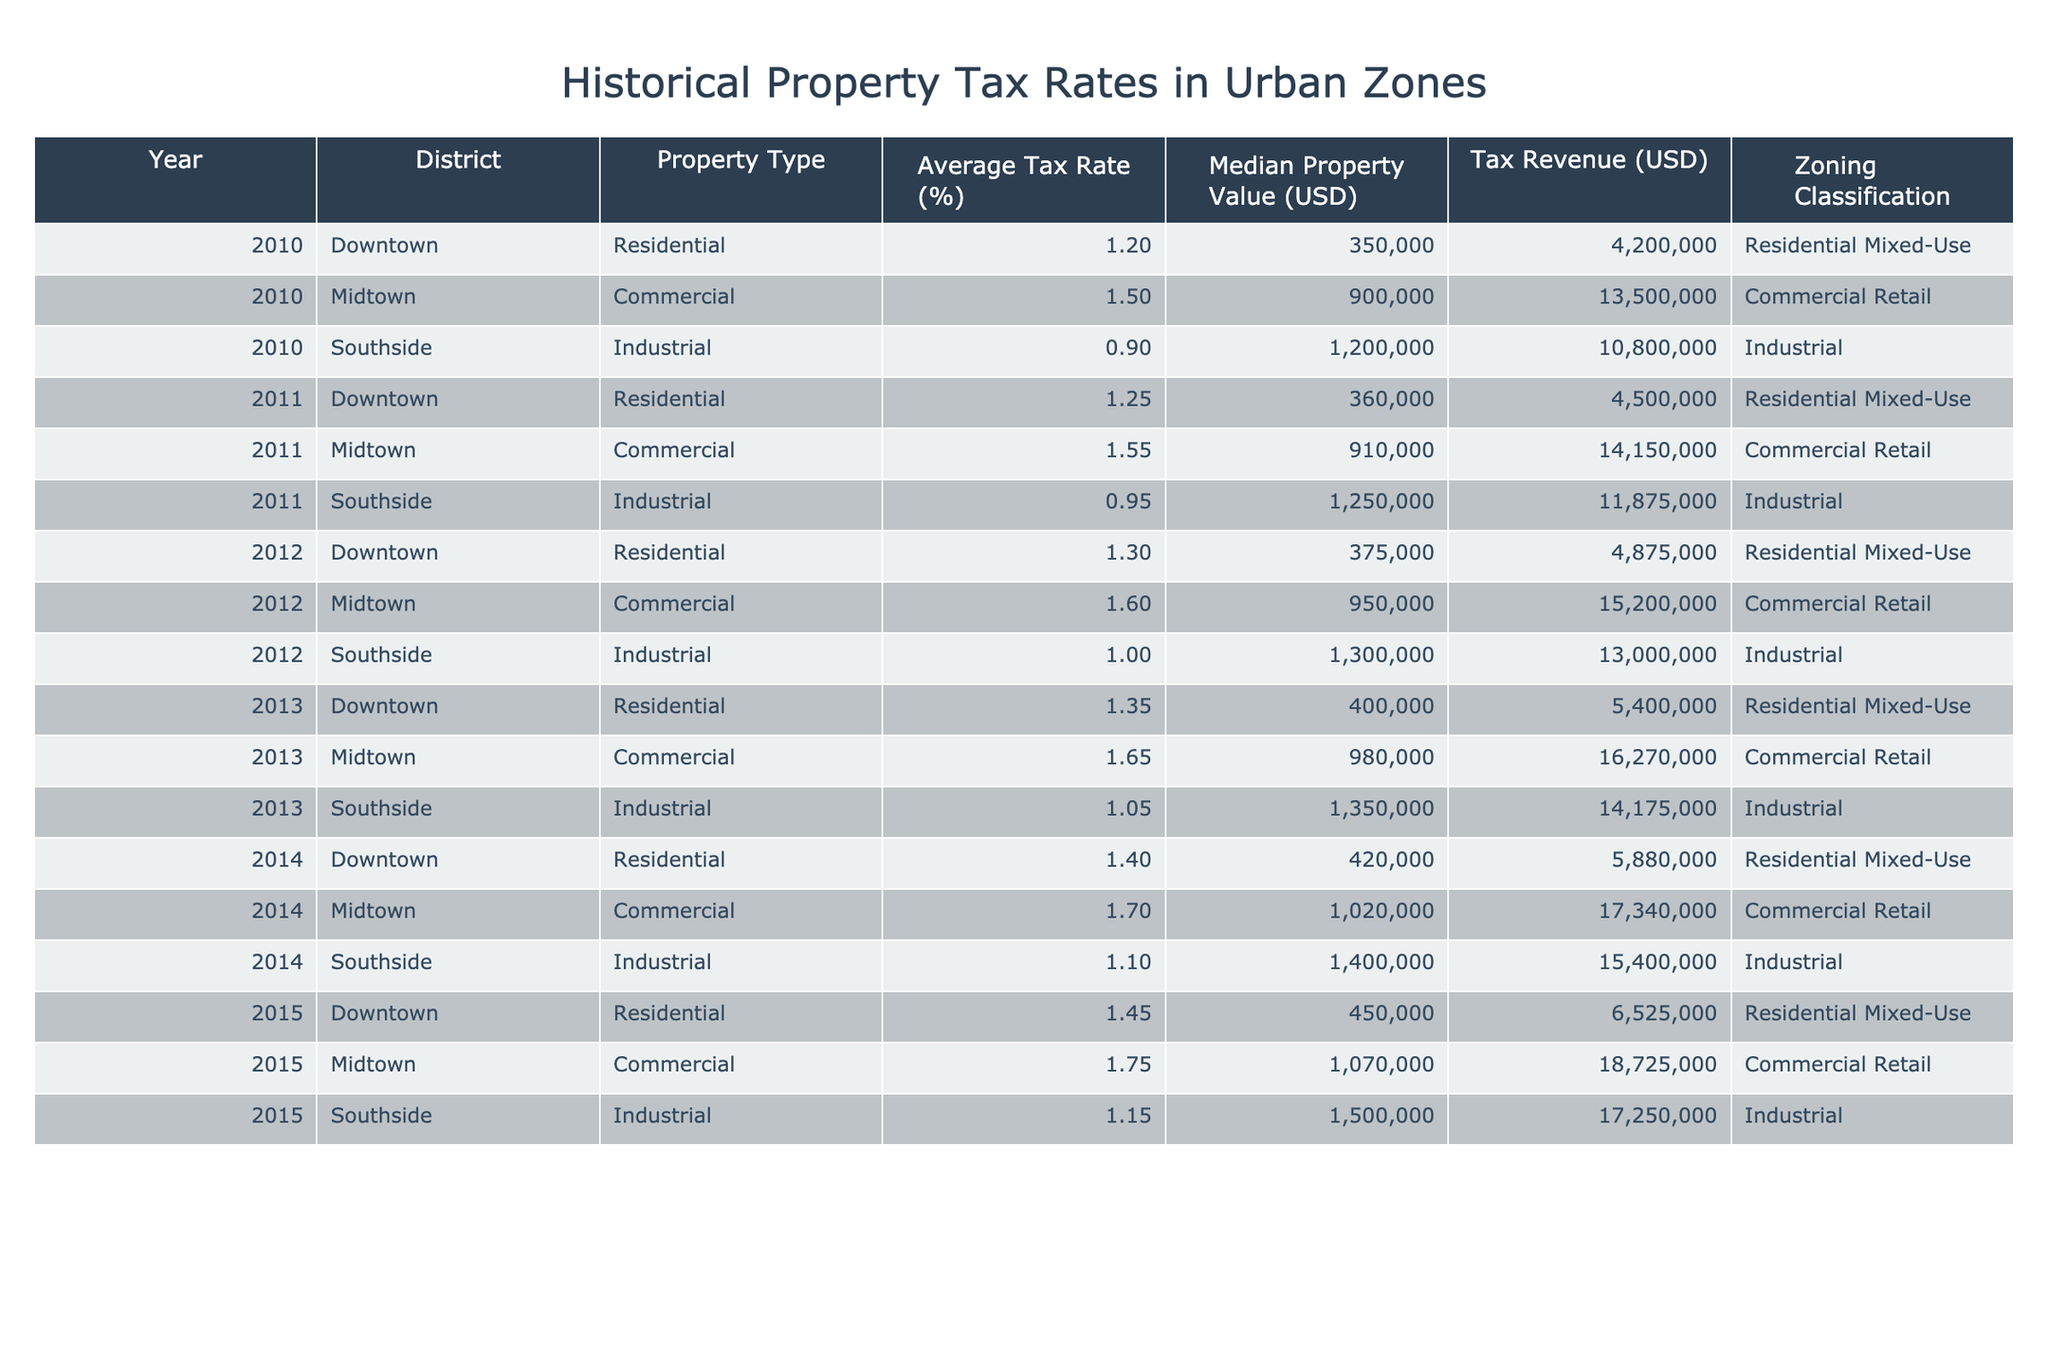What was the average tax rate for the Southside district in 2012? In 2012, the average tax rate for Southside is listed as 1.00%. There is only one entry for Southside in that year.
Answer: 1.00% Which property type had the highest median property value in 2014? In 2014, the median property values are Residential 420000 USD, Commercial 1020000 USD, and Industrial 1400000 USD. Industrial has the highest value.
Answer: Industrial Did the average tax rate for Midtown commercial properties increase every year from 2010 to 2015? The average tax rates for Midtown commercial properties from 2010 to 2015 are as follows: 1.50%, 1.55%, 1.60%, 1.65%, 1.70%, and 1.75%. It consistently increased, confirming the statement as true.
Answer: Yes What is the total tax revenue for the Downtown district from 2010 to 2015? Summing tax revenues for Downtown from 2010 to 2015 gives us 4200000 + 4500000 + 4875000 + 5400000 + 5880000 + 6525000 = 31950000 USD.
Answer: 31950000 What was the average increase in the average tax rate across all districts from 2010 to 2015? The average tax rates are: 1.20%, 1.25%, 1.30%, 1.35%, 1.40%, 1.45% (Downtown) = average of 1.30%; for Midtown: 1.50%, 1.55%, 1.60%, 1.65%, 1.70%, 1.75% = 1.63%; for Southside: 0.90%, 0.95%, 1.00%, 1.05%, 1.10%, 1.15% = 1.025%. The overall average is (1.30% + 1.63% + 1.025%)/3 = 1.3183%. Therefore, the increase averages approximately 0.0656% per year from 2010 to 2015.
Answer: 0.0656% Was there a property type in 2013 that had a lower average tax rate than the Southside industrial properties? In 2013, the average tax rates were: Downtown Residential 1.35%, Midtown Commercial 1.65%, and Southside Industrial 1.05%. Therefore, no other property type had a lower average tax rate than Southside Industrial.
Answer: No 